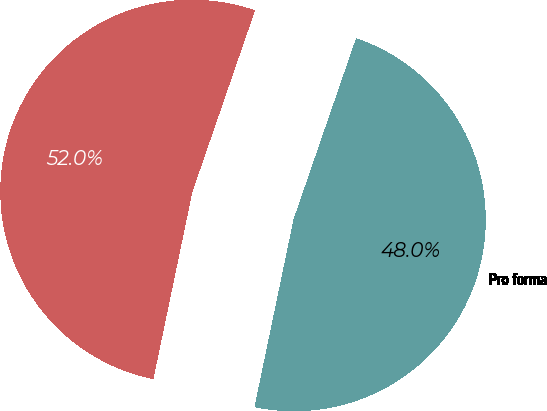<chart> <loc_0><loc_0><loc_500><loc_500><pie_chart><fcel>As reported<fcel>Pro forma<nl><fcel>52.02%<fcel>47.98%<nl></chart> 